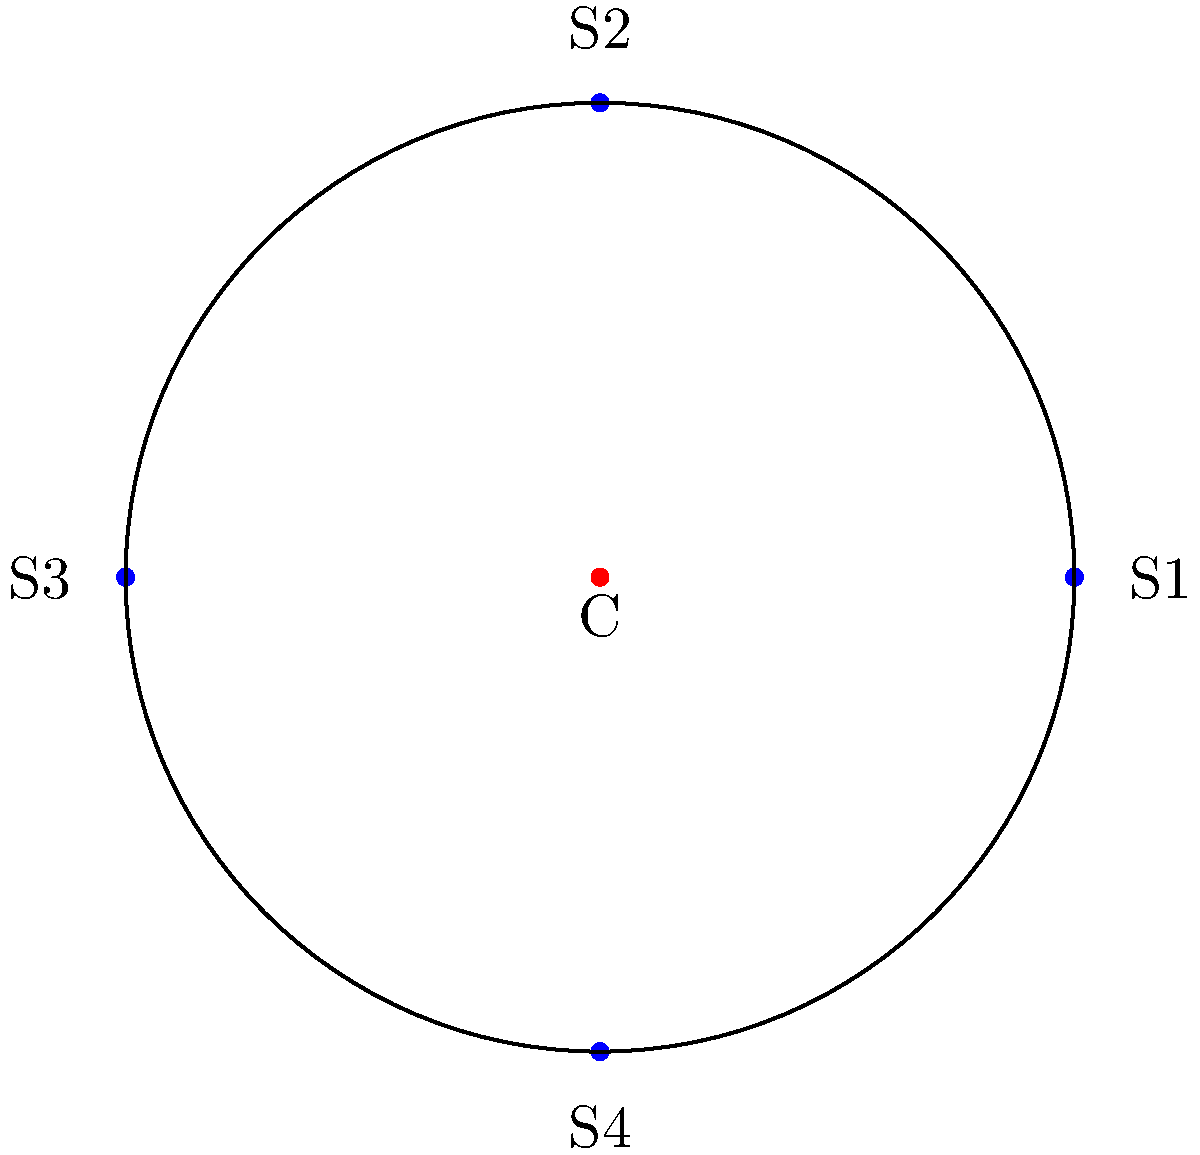At our favorite artist's concert, you notice the stage has a circular layout with four speakers positioned symmetrically around it. The center of the stage is marked as point C, and the speakers are labeled S1, S2, S3, and S4. What is the order of the symmetry group for this stage layout? Let's analyze the symmetry group of this stage layout step-by-step:

1) Rotational symmetry:
   - The stage has 4-fold rotational symmetry (90° rotations).
   - It also has 2-fold rotational symmetry (180° rotations).
   - The identity transformation (0° or 360° rotation) is always present.
   - Total rotational symmetries: 4

2) Reflection symmetry:
   - There are 4 lines of reflection:
     a) Vertical line through C
     b) Horizontal line through C
     c) Diagonal line through C from top-left to bottom-right
     d) Diagonal line through C from top-right to bottom-left
   - Total reflection symmetries: 4

3) The symmetry group of this layout is known as the dihedral group $D_4$.

4) The order of a dihedral group $D_n$ is given by the formula: $|D_n| = 2n$

5) In this case, $n = 4$, so the order of the group is:
   $|D_4| = 2 * 4 = 8$

Therefore, the order of the symmetry group for this stage layout is 8.
Answer: 8 